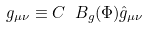<formula> <loc_0><loc_0><loc_500><loc_500>g _ { \mu \nu } \equiv C \ B _ { g } ( \Phi ) \hat { g } _ { \mu \nu }</formula> 